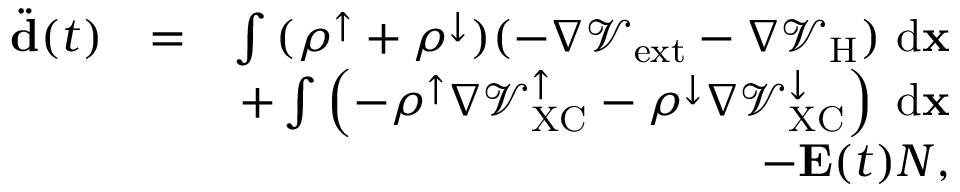Convert formula to latex. <formula><loc_0><loc_0><loc_500><loc_500>\begin{array} { r l r } { \ddot { d } ( t ) } & { = } & { \int { ( \rho ^ { \uparrow } + \rho ^ { \downarrow } ) ( - \nabla \mathcal { V } _ { e x t } - \nabla \mathcal { V } _ { H } ) \ d { x } } } \\ & { + \int { \left ( - \rho ^ { \uparrow } \nabla \mathcal { V } _ { X C } ^ { \uparrow } - \rho ^ { \downarrow } \nabla \mathcal { V } _ { X C } ^ { \downarrow } \right ) \ d { x } } } \\ & { - { E } ( t ) N , } \end{array}</formula> 